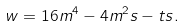Convert formula to latex. <formula><loc_0><loc_0><loc_500><loc_500>w = 1 6 m ^ { 4 } - 4 m ^ { 2 } s - t s .</formula> 